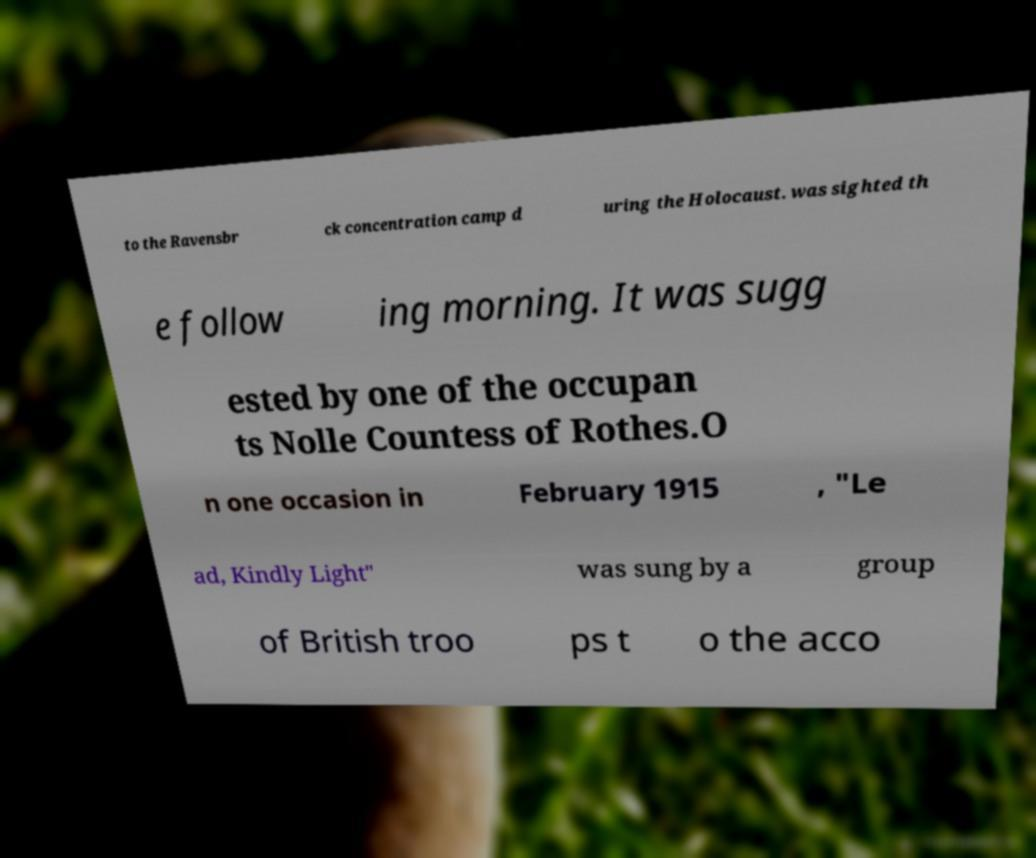Can you accurately transcribe the text from the provided image for me? to the Ravensbr ck concentration camp d uring the Holocaust. was sighted th e follow ing morning. It was sugg ested by one of the occupan ts Nolle Countess of Rothes.O n one occasion in February 1915 , "Le ad, Kindly Light" was sung by a group of British troo ps t o the acco 